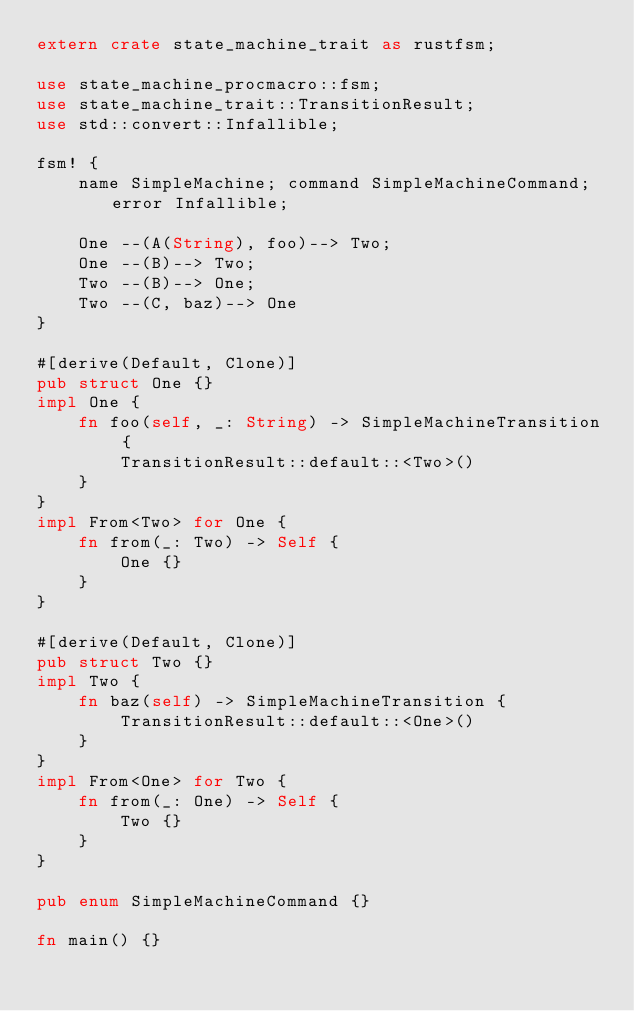<code> <loc_0><loc_0><loc_500><loc_500><_Rust_>extern crate state_machine_trait as rustfsm;

use state_machine_procmacro::fsm;
use state_machine_trait::TransitionResult;
use std::convert::Infallible;

fsm! {
    name SimpleMachine; command SimpleMachineCommand; error Infallible;

    One --(A(String), foo)--> Two;
    One --(B)--> Two;
    Two --(B)--> One;
    Two --(C, baz)--> One
}

#[derive(Default, Clone)]
pub struct One {}
impl One {
    fn foo(self, _: String) -> SimpleMachineTransition {
        TransitionResult::default::<Two>()
    }
}
impl From<Two> for One {
    fn from(_: Two) -> Self {
        One {}
    }
}

#[derive(Default, Clone)]
pub struct Two {}
impl Two {
    fn baz(self) -> SimpleMachineTransition {
        TransitionResult::default::<One>()
    }
}
impl From<One> for Two {
    fn from(_: One) -> Self {
        Two {}
    }
}

pub enum SimpleMachineCommand {}

fn main() {}
</code> 